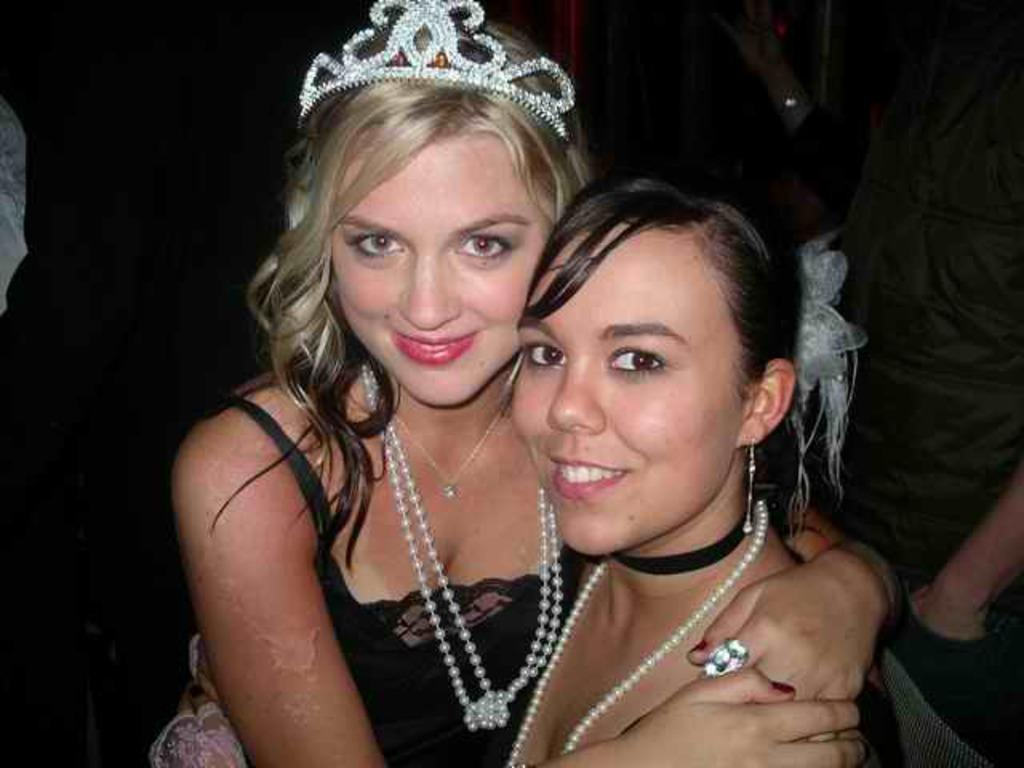How many girls are in the image? There are two girls in the center of the image. Can you describe the girls' position in the image? The girls are in the center of the image. What else can be seen in the image besides the two girls? There are other people in the background area of the image. What type of place is the girls' respect for the crowd displayed in the image? There is no mention of a place, respect, or crowd in the image. The image only shows two girls in the center and other people in the background. 